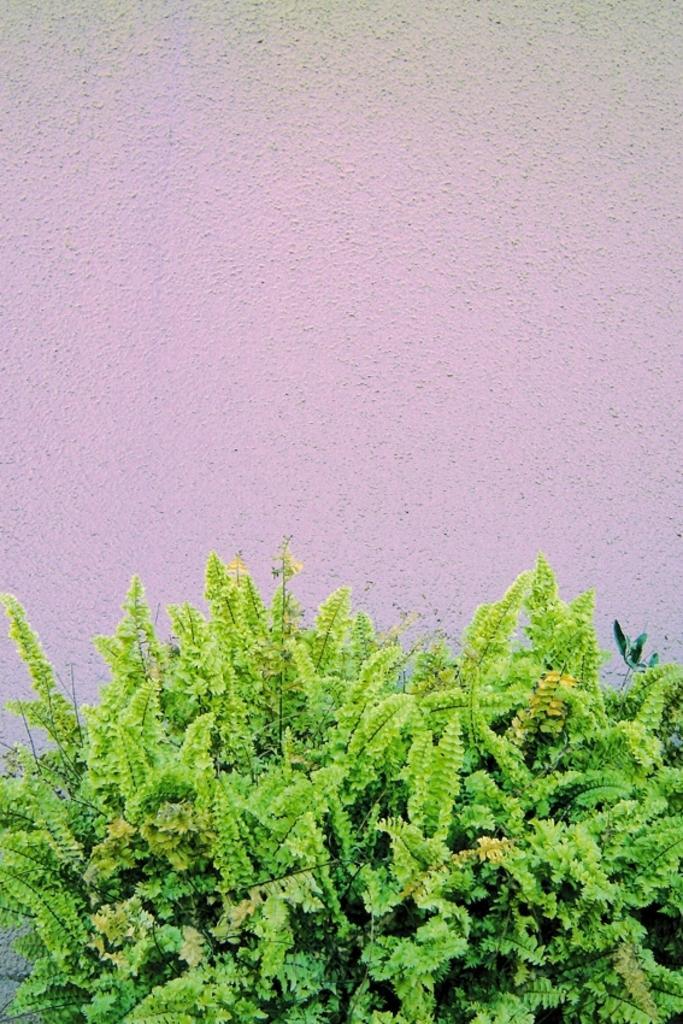Could you give a brief overview of what you see in this image? This image consists of green plants. In the background, we can see a wall. 